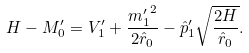Convert formula to latex. <formula><loc_0><loc_0><loc_500><loc_500>H - M ^ { \prime } _ { 0 } = V ^ { \prime } _ { 1 } + \frac { { m ^ { \prime } _ { 1 } } ^ { 2 } } { 2 \hat { r } _ { 0 } } - { \hat { p } ^ { \prime } } _ { 1 } \sqrt { \frac { 2 H } { \hat { r } _ { 0 } } } .</formula> 